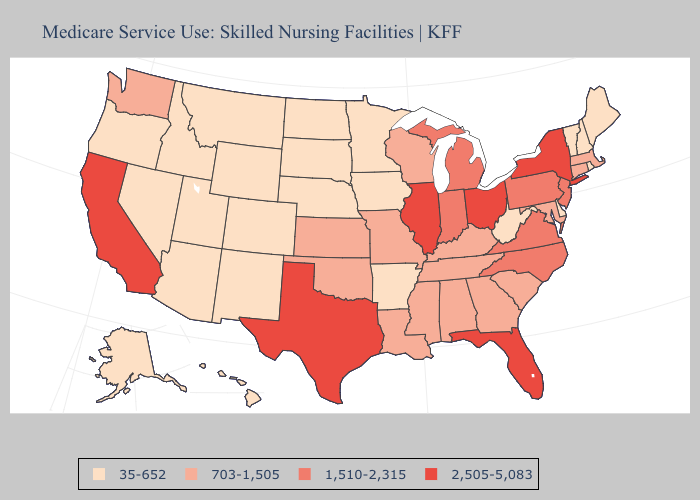Does Wisconsin have the lowest value in the MidWest?
Short answer required. No. Does Delaware have the lowest value in the South?
Concise answer only. Yes. Does New York have the highest value in the Northeast?
Short answer required. Yes. What is the value of Kentucky?
Keep it brief. 703-1,505. Which states have the lowest value in the MidWest?
Be succinct. Iowa, Minnesota, Nebraska, North Dakota, South Dakota. What is the value of Iowa?
Concise answer only. 35-652. Name the states that have a value in the range 1,510-2,315?
Concise answer only. Indiana, Michigan, New Jersey, North Carolina, Pennsylvania, Virginia. Does South Carolina have the lowest value in the USA?
Short answer required. No. Does Alabama have a higher value than Massachusetts?
Give a very brief answer. No. Name the states that have a value in the range 703-1,505?
Write a very short answer. Alabama, Connecticut, Georgia, Kansas, Kentucky, Louisiana, Maryland, Massachusetts, Mississippi, Missouri, Oklahoma, South Carolina, Tennessee, Washington, Wisconsin. Is the legend a continuous bar?
Keep it brief. No. Which states have the lowest value in the USA?
Answer briefly. Alaska, Arizona, Arkansas, Colorado, Delaware, Hawaii, Idaho, Iowa, Maine, Minnesota, Montana, Nebraska, Nevada, New Hampshire, New Mexico, North Dakota, Oregon, Rhode Island, South Dakota, Utah, Vermont, West Virginia, Wyoming. What is the value of Wyoming?
Short answer required. 35-652. What is the value of Nevada?
Be succinct. 35-652. What is the value of North Dakota?
Give a very brief answer. 35-652. 